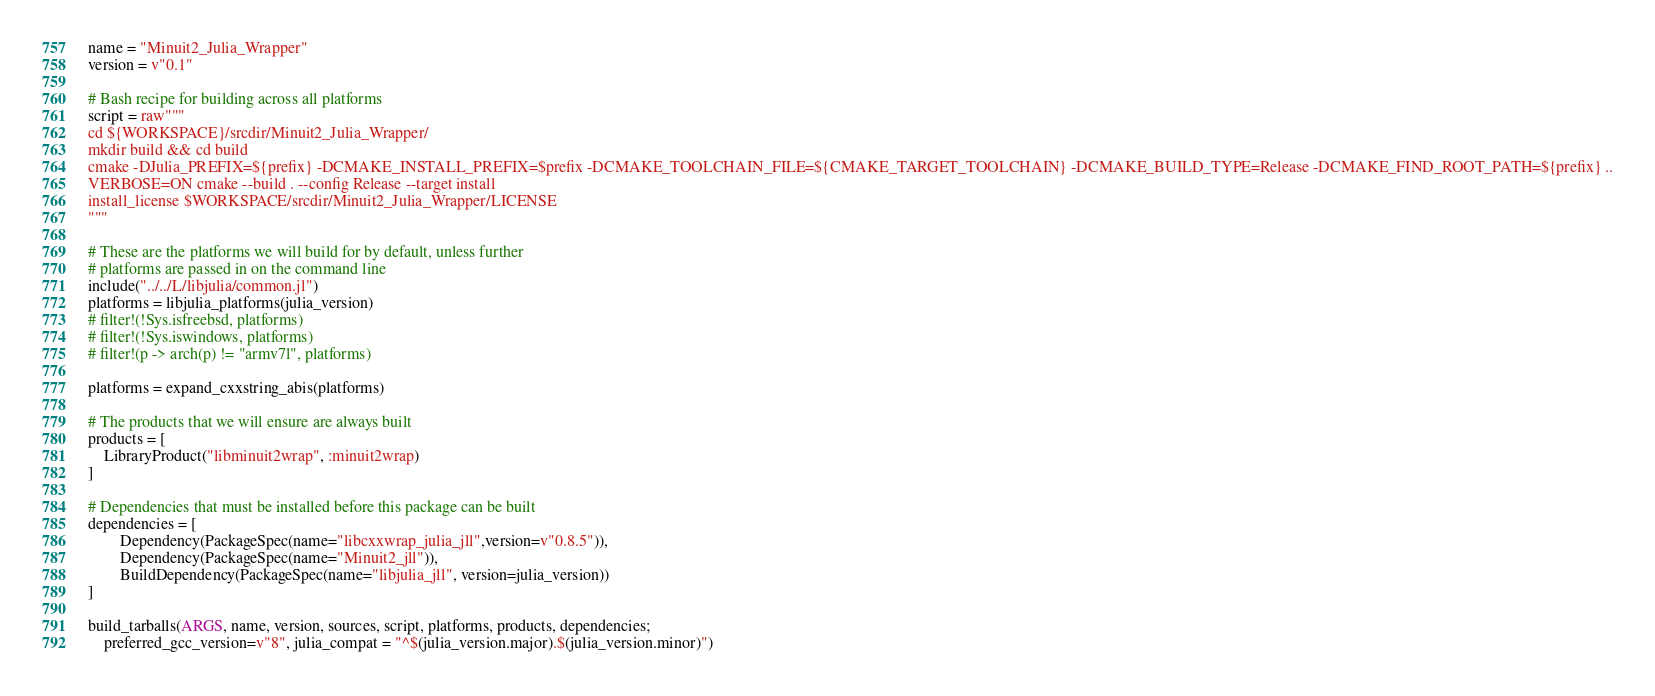Convert code to text. <code><loc_0><loc_0><loc_500><loc_500><_Julia_>
name = "Minuit2_Julia_Wrapper"
version = v"0.1"

# Bash recipe for building across all platforms
script = raw"""
cd ${WORKSPACE}/srcdir/Minuit2_Julia_Wrapper/
mkdir build && cd build
cmake -DJulia_PREFIX=${prefix} -DCMAKE_INSTALL_PREFIX=$prefix -DCMAKE_TOOLCHAIN_FILE=${CMAKE_TARGET_TOOLCHAIN} -DCMAKE_BUILD_TYPE=Release -DCMAKE_FIND_ROOT_PATH=${prefix} ..
VERBOSE=ON cmake --build . --config Release --target install
install_license $WORKSPACE/srcdir/Minuit2_Julia_Wrapper/LICENSE 
"""

# These are the platforms we will build for by default, unless further
# platforms are passed in on the command line
include("../../L/libjulia/common.jl")
platforms = libjulia_platforms(julia_version)
# filter!(!Sys.isfreebsd, platforms)
# filter!(!Sys.iswindows, platforms)
# filter!(p -> arch(p) != "armv7l", platforms)

platforms = expand_cxxstring_abis(platforms)

# The products that we will ensure are always built
products = [
    LibraryProduct("libminuit2wrap", :minuit2wrap)
]

# Dependencies that must be installed before this package can be built
dependencies = [
        Dependency(PackageSpec(name="libcxxwrap_julia_jll",version=v"0.8.5")),
        Dependency(PackageSpec(name="Minuit2_jll")),
        BuildDependency(PackageSpec(name="libjulia_jll", version=julia_version))
]

build_tarballs(ARGS, name, version, sources, script, platforms, products, dependencies; 
    preferred_gcc_version=v"8", julia_compat = "^$(julia_version.major).$(julia_version.minor)")
</code> 